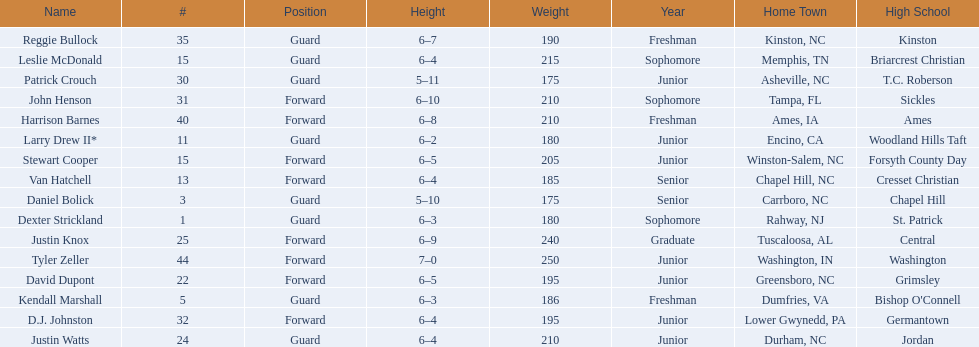Tallest player on the team Tyler Zeller. 